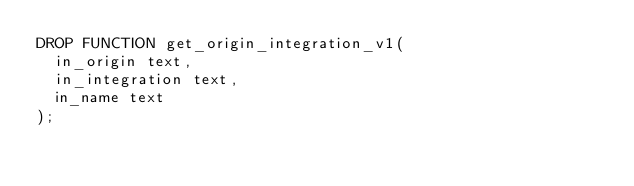<code> <loc_0><loc_0><loc_500><loc_500><_SQL_>DROP FUNCTION get_origin_integration_v1(
  in_origin text,
  in_integration text,
  in_name text
);
</code> 